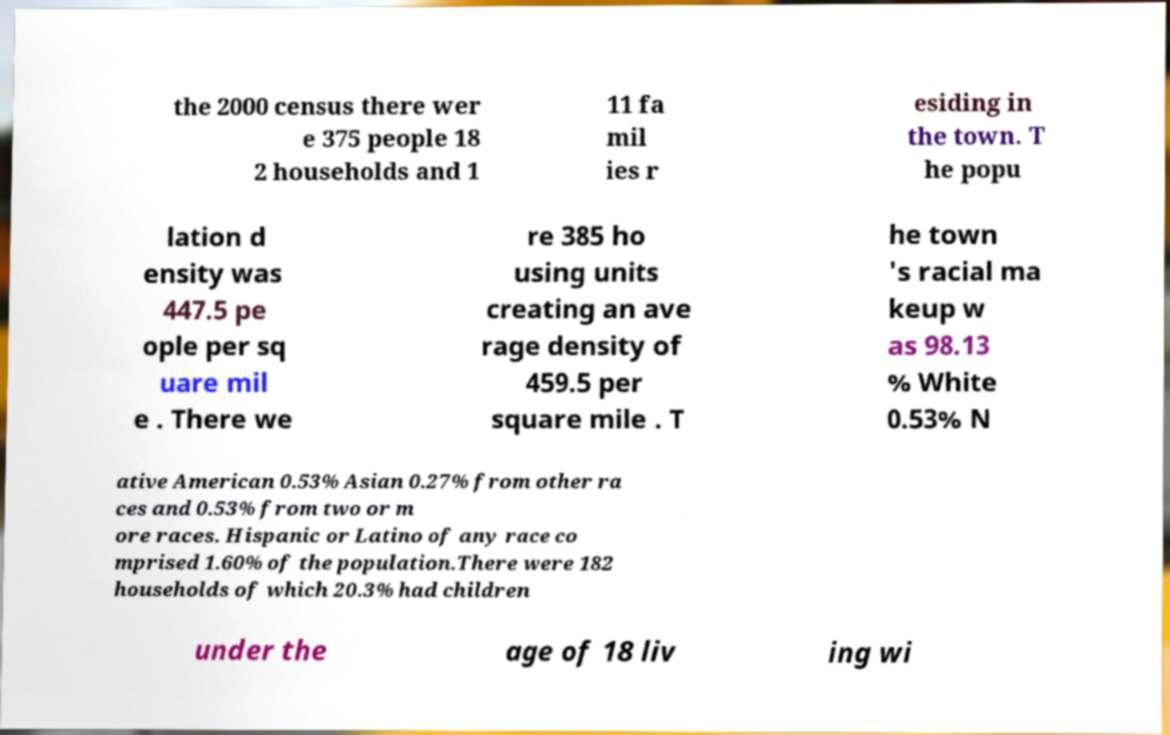I need the written content from this picture converted into text. Can you do that? the 2000 census there wer e 375 people 18 2 households and 1 11 fa mil ies r esiding in the town. T he popu lation d ensity was 447.5 pe ople per sq uare mil e . There we re 385 ho using units creating an ave rage density of 459.5 per square mile . T he town 's racial ma keup w as 98.13 % White 0.53% N ative American 0.53% Asian 0.27% from other ra ces and 0.53% from two or m ore races. Hispanic or Latino of any race co mprised 1.60% of the population.There were 182 households of which 20.3% had children under the age of 18 liv ing wi 